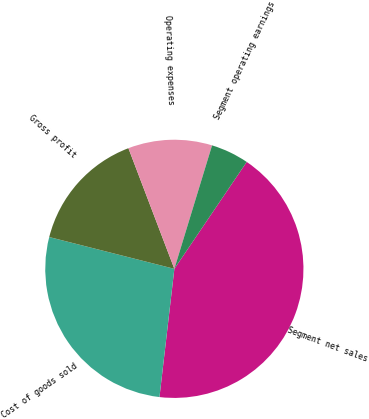Convert chart to OTSL. <chart><loc_0><loc_0><loc_500><loc_500><pie_chart><fcel>Segment net sales<fcel>Cost of goods sold<fcel>Gross profit<fcel>Operating expenses<fcel>Segment operating earnings<nl><fcel>42.37%<fcel>27.12%<fcel>15.25%<fcel>10.51%<fcel>4.75%<nl></chart> 